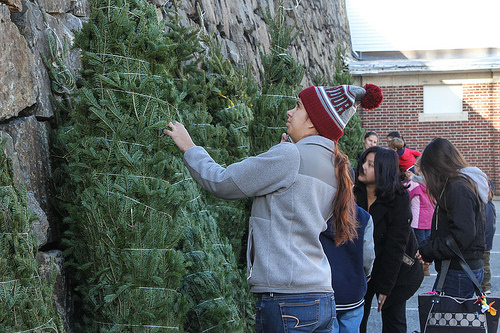<image>
Is there a person on the tree? No. The person is not positioned on the tree. They may be near each other, but the person is not supported by or resting on top of the tree. Is the hat on the christmas tree? No. The hat is not positioned on the christmas tree. They may be near each other, but the hat is not supported by or resting on top of the christmas tree. 